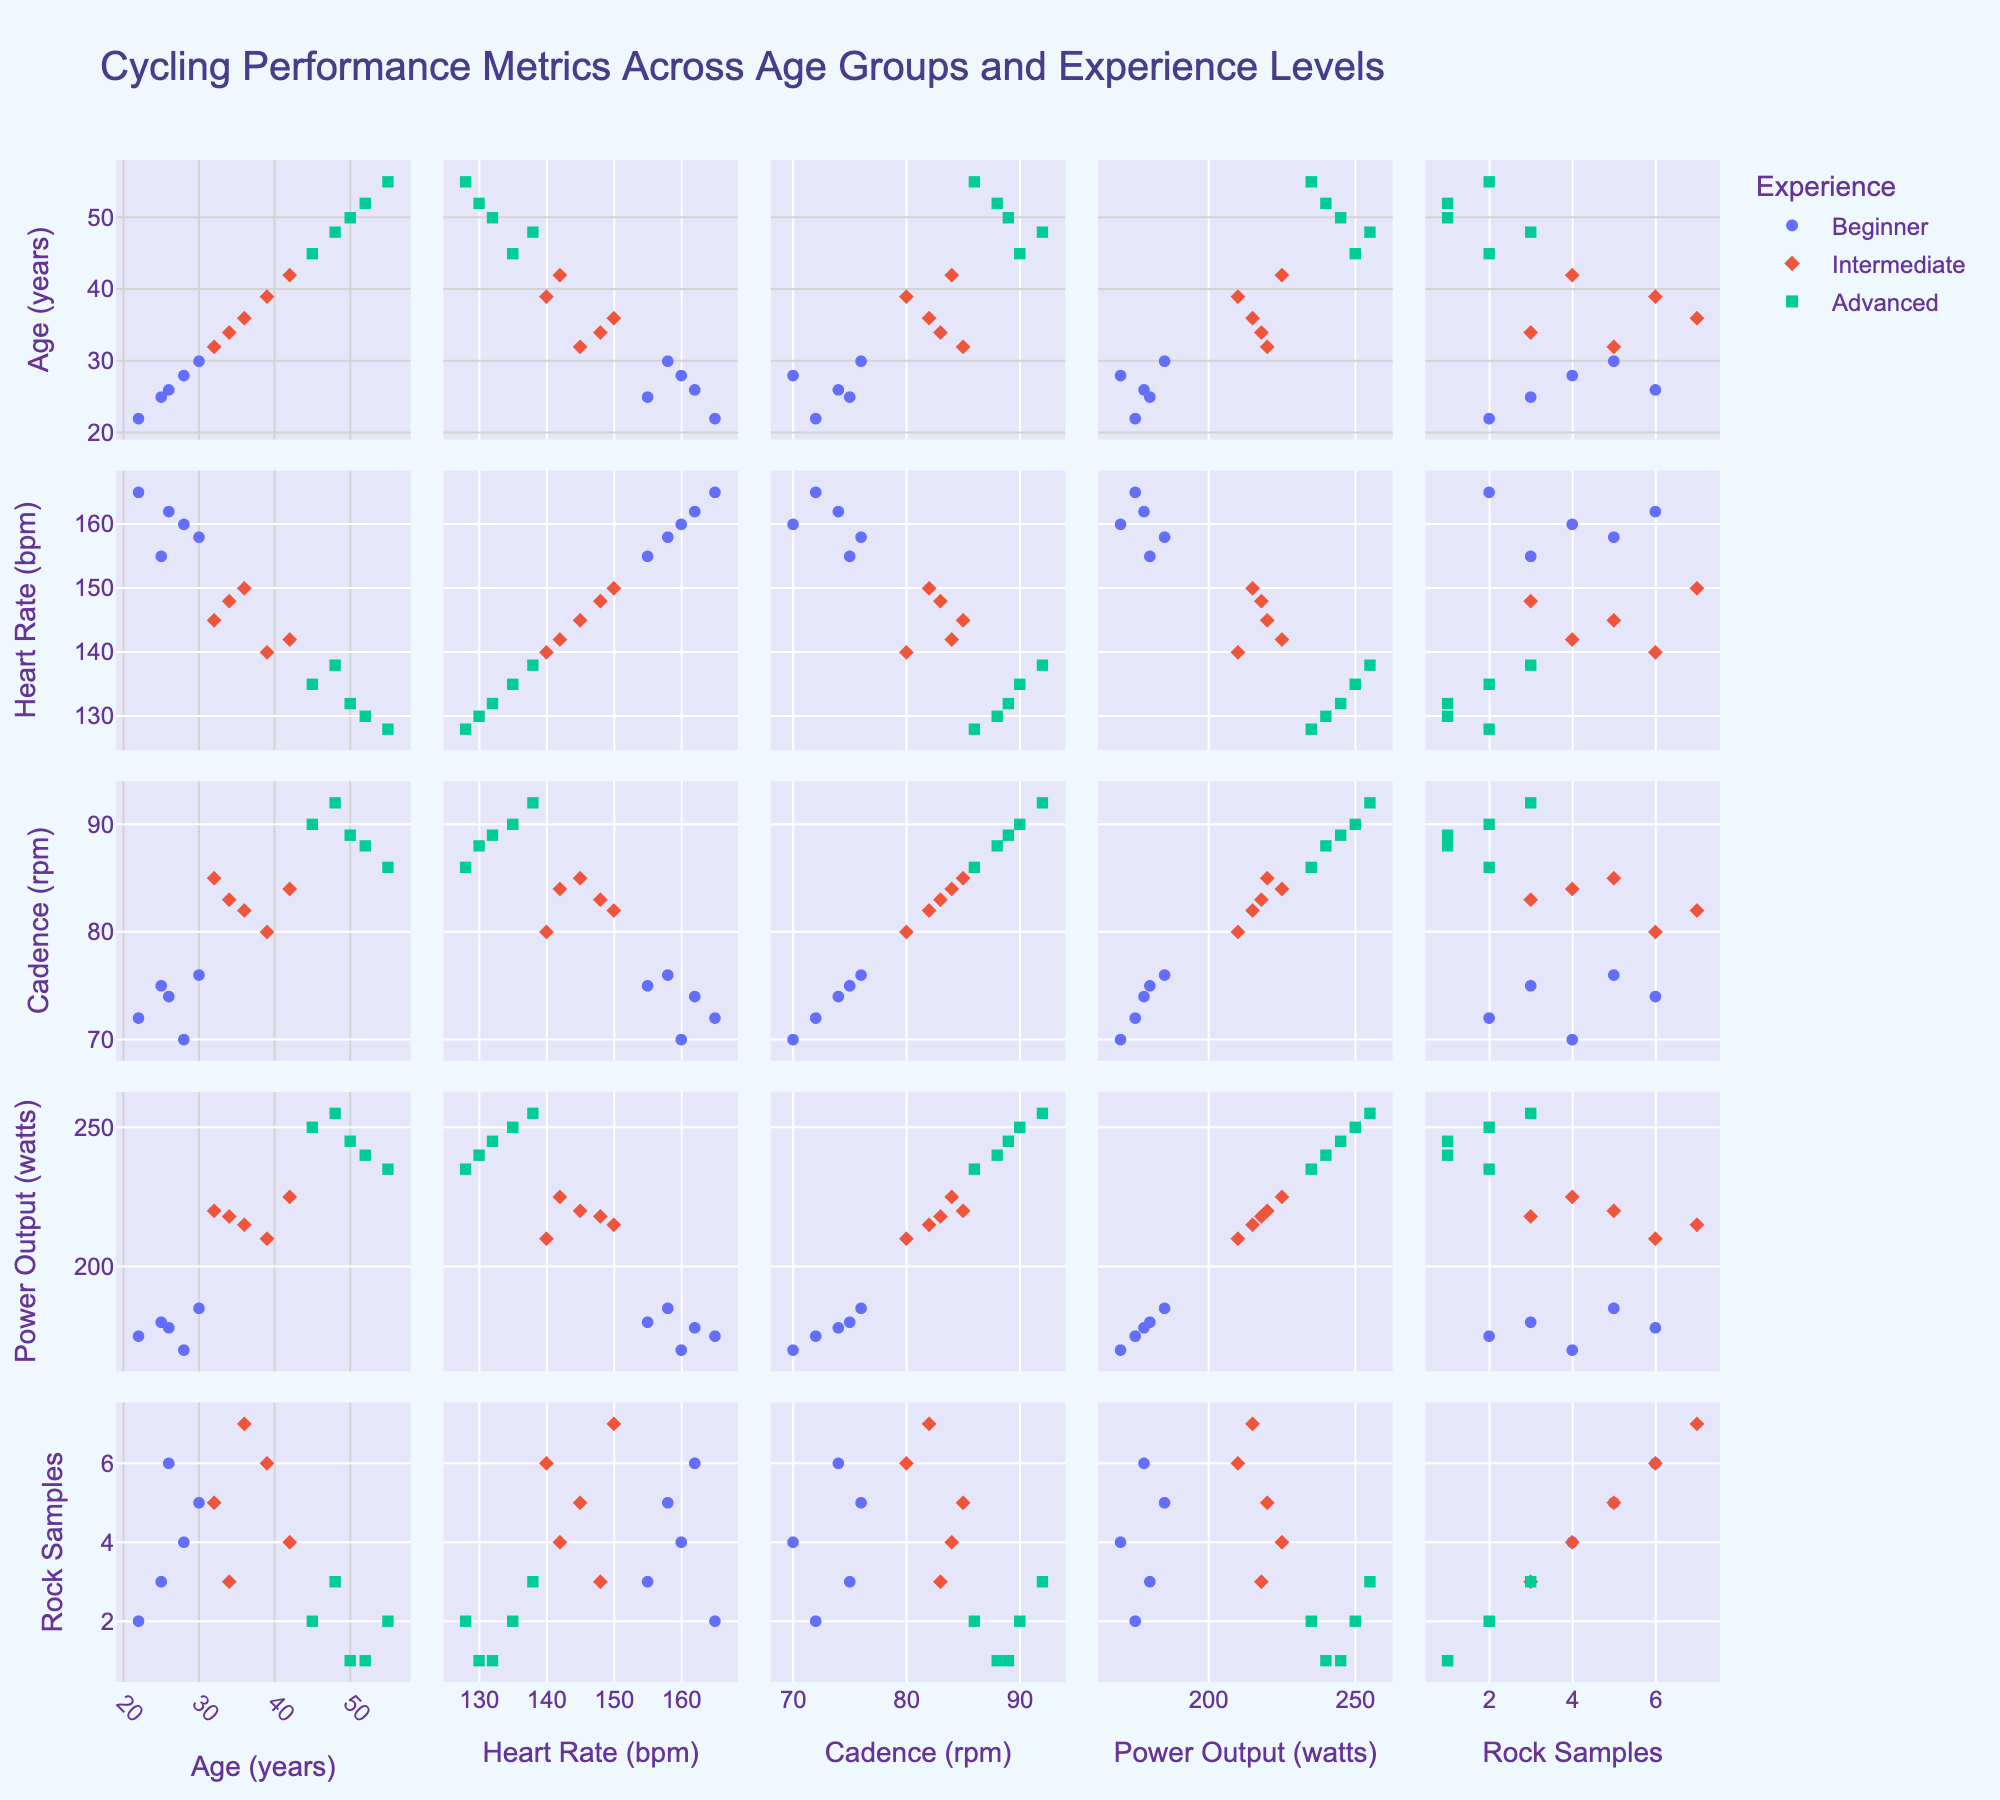What's the title of the plot? The title of the plot is usually located at the top center of the figure. In this case, it reads, "Cycling Performance Metrics Across Age Groups and Experience Levels".
Answer: Cycling Performance Metrics Across Age Groups and Experience Levels How are the experience levels differentiated in the plot? Experience levels are differentiated by color and symbol. Beginner, Intermediate, and Advanced groups are each given a unique color and symbol as shown in the legend.
Answer: By color and symbol What metric is shown on the y-axis of the scatter plot in the bottom row and fourth column? The y-axis on the bottom row and fourth column shows the "Power Output" dimension, as indicated by the dimension labels on that axis.
Answer: Power Output What's the range of heart rate values present in the dataset? To find the range of heart rate values, observe the x-axes and y-axes of the plots related to heart rate. The heart rate values range from approximately 128 to 165 bpm.
Answer: Approximately 128 to 165 bpm Which experience level tends to have the highest cadence? By identifying cadence values and corresponding experience levels visually, you can see that the Advanced group generally occupies the higher end of the cadence range, indicating they tend to have the highest cadence.
Answer: Advanced What is the average number of rock samples collected by the Intermediate group? Locate the points labeled as Intermediate in the Rock Samples dimension, then sum the corresponding values and divide by the number of Intermediate data points (5, 6, 7, 4, 3). (5+6+7+4+3)/5 = 5
Answer: 5 Which age group has the lowest power output value? Find the points with the lowest power output values and check their corresponding ages. The lowest power output value (170) belongs to a 28-year-old Beginner.
Answer: 28-year-old Between Beginner and Advanced cyclists, who has a wider range of heart rates? Compare the spread of heart rate values for Beginner and Advanced cyclists across the y-axes of related plots. Beginners have a wider range from around 155 to 165 bpm, while Advanced ranges from around 128 to 138 bpm.
Answer: Beginner Does cadence seem to increase with experience level? Observe the trends in cadence across experience levels in the scatter plots. Advanced cyclists generally have higher cadence, followed by Intermediate and then Beginner, indicating an increase with experience.
Answer: Yes Is there a noticeable correlation between age and rock samples collected? Examine the plots of Age versus Rock Samples Collected. There does not appear to be a distinct correlation, as rock samples collected are spread across ages without a clear trend.
Answer: No 